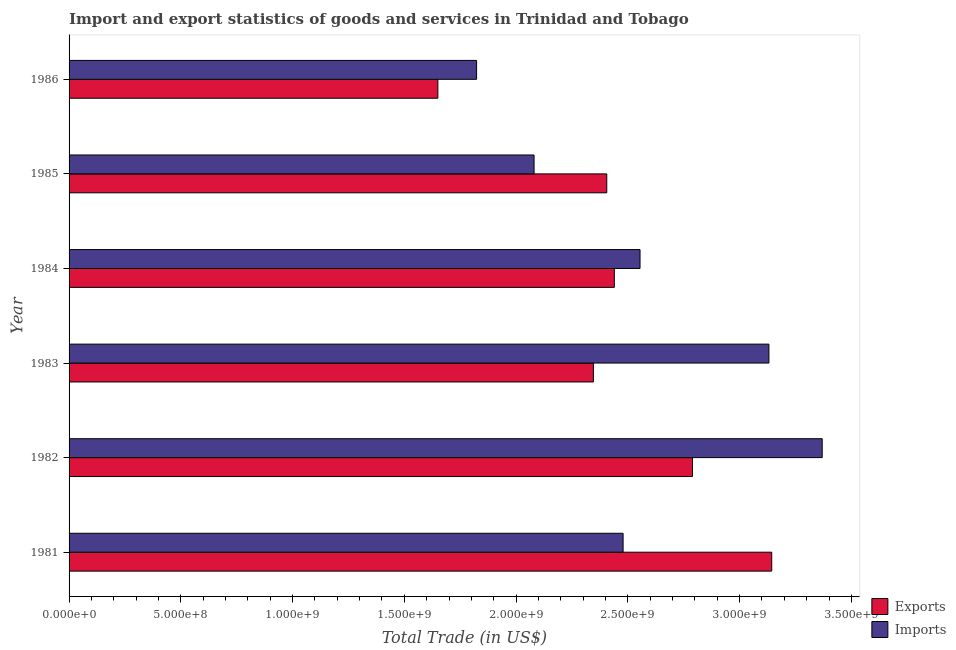How many different coloured bars are there?
Offer a very short reply. 2. How many groups of bars are there?
Offer a terse response. 6. Are the number of bars per tick equal to the number of legend labels?
Provide a succinct answer. Yes. How many bars are there on the 2nd tick from the top?
Give a very brief answer. 2. What is the label of the 4th group of bars from the top?
Keep it short and to the point. 1983. In how many cases, is the number of bars for a given year not equal to the number of legend labels?
Offer a terse response. 0. What is the imports of goods and services in 1983?
Your answer should be very brief. 3.13e+09. Across all years, what is the maximum export of goods and services?
Ensure brevity in your answer.  3.14e+09. Across all years, what is the minimum export of goods and services?
Ensure brevity in your answer.  1.65e+09. In which year was the imports of goods and services minimum?
Offer a terse response. 1986. What is the total export of goods and services in the graph?
Keep it short and to the point. 1.48e+1. What is the difference between the export of goods and services in 1981 and that in 1986?
Keep it short and to the point. 1.49e+09. What is the difference between the imports of goods and services in 1985 and the export of goods and services in 1982?
Your response must be concise. -7.09e+08. What is the average imports of goods and services per year?
Offer a terse response. 2.57e+09. In the year 1986, what is the difference between the imports of goods and services and export of goods and services?
Keep it short and to the point. 1.73e+08. What is the ratio of the imports of goods and services in 1982 to that in 1983?
Keep it short and to the point. 1.08. Is the imports of goods and services in 1983 less than that in 1986?
Offer a terse response. No. Is the difference between the export of goods and services in 1985 and 1986 greater than the difference between the imports of goods and services in 1985 and 1986?
Ensure brevity in your answer.  Yes. What is the difference between the highest and the second highest imports of goods and services?
Ensure brevity in your answer.  2.38e+08. What is the difference between the highest and the lowest imports of goods and services?
Keep it short and to the point. 1.55e+09. In how many years, is the imports of goods and services greater than the average imports of goods and services taken over all years?
Make the answer very short. 2. Is the sum of the imports of goods and services in 1981 and 1983 greater than the maximum export of goods and services across all years?
Offer a very short reply. Yes. What does the 1st bar from the top in 1985 represents?
Provide a short and direct response. Imports. What does the 1st bar from the bottom in 1986 represents?
Offer a very short reply. Exports. Are all the bars in the graph horizontal?
Your response must be concise. Yes. What is the difference between two consecutive major ticks on the X-axis?
Your response must be concise. 5.00e+08. Does the graph contain grids?
Offer a terse response. No. Where does the legend appear in the graph?
Offer a very short reply. Bottom right. How many legend labels are there?
Provide a succinct answer. 2. What is the title of the graph?
Keep it short and to the point. Import and export statistics of goods and services in Trinidad and Tobago. What is the label or title of the X-axis?
Give a very brief answer. Total Trade (in US$). What is the Total Trade (in US$) in Exports in 1981?
Keep it short and to the point. 3.14e+09. What is the Total Trade (in US$) in Imports in 1981?
Offer a terse response. 2.48e+09. What is the Total Trade (in US$) in Exports in 1982?
Your response must be concise. 2.79e+09. What is the Total Trade (in US$) of Imports in 1982?
Your response must be concise. 3.37e+09. What is the Total Trade (in US$) of Exports in 1983?
Ensure brevity in your answer.  2.35e+09. What is the Total Trade (in US$) of Imports in 1983?
Provide a short and direct response. 3.13e+09. What is the Total Trade (in US$) in Exports in 1984?
Your response must be concise. 2.44e+09. What is the Total Trade (in US$) of Imports in 1984?
Give a very brief answer. 2.55e+09. What is the Total Trade (in US$) of Exports in 1985?
Provide a short and direct response. 2.41e+09. What is the Total Trade (in US$) in Imports in 1985?
Your answer should be compact. 2.08e+09. What is the Total Trade (in US$) of Exports in 1986?
Offer a very short reply. 1.65e+09. What is the Total Trade (in US$) of Imports in 1986?
Provide a succinct answer. 1.82e+09. Across all years, what is the maximum Total Trade (in US$) in Exports?
Make the answer very short. 3.14e+09. Across all years, what is the maximum Total Trade (in US$) in Imports?
Ensure brevity in your answer.  3.37e+09. Across all years, what is the minimum Total Trade (in US$) of Exports?
Offer a very short reply. 1.65e+09. Across all years, what is the minimum Total Trade (in US$) in Imports?
Offer a very short reply. 1.82e+09. What is the total Total Trade (in US$) of Exports in the graph?
Give a very brief answer. 1.48e+1. What is the total Total Trade (in US$) of Imports in the graph?
Your response must be concise. 1.54e+1. What is the difference between the Total Trade (in US$) of Exports in 1981 and that in 1982?
Keep it short and to the point. 3.55e+08. What is the difference between the Total Trade (in US$) in Imports in 1981 and that in 1982?
Your response must be concise. -8.91e+08. What is the difference between the Total Trade (in US$) of Exports in 1981 and that in 1983?
Your answer should be very brief. 7.98e+08. What is the difference between the Total Trade (in US$) in Imports in 1981 and that in 1983?
Your answer should be compact. -6.52e+08. What is the difference between the Total Trade (in US$) of Exports in 1981 and that in 1984?
Give a very brief answer. 7.04e+08. What is the difference between the Total Trade (in US$) in Imports in 1981 and that in 1984?
Your response must be concise. -7.58e+07. What is the difference between the Total Trade (in US$) in Exports in 1981 and that in 1985?
Make the answer very short. 7.38e+08. What is the difference between the Total Trade (in US$) in Imports in 1981 and that in 1985?
Your response must be concise. 3.98e+08. What is the difference between the Total Trade (in US$) in Exports in 1981 and that in 1986?
Your answer should be compact. 1.49e+09. What is the difference between the Total Trade (in US$) in Imports in 1981 and that in 1986?
Your answer should be very brief. 6.55e+08. What is the difference between the Total Trade (in US$) in Exports in 1982 and that in 1983?
Your response must be concise. 4.43e+08. What is the difference between the Total Trade (in US$) of Imports in 1982 and that in 1983?
Your answer should be compact. 2.38e+08. What is the difference between the Total Trade (in US$) in Exports in 1982 and that in 1984?
Your answer should be very brief. 3.50e+08. What is the difference between the Total Trade (in US$) in Imports in 1982 and that in 1984?
Provide a short and direct response. 8.15e+08. What is the difference between the Total Trade (in US$) of Exports in 1982 and that in 1985?
Ensure brevity in your answer.  3.83e+08. What is the difference between the Total Trade (in US$) in Imports in 1982 and that in 1985?
Keep it short and to the point. 1.29e+09. What is the difference between the Total Trade (in US$) in Exports in 1982 and that in 1986?
Ensure brevity in your answer.  1.14e+09. What is the difference between the Total Trade (in US$) in Imports in 1982 and that in 1986?
Offer a terse response. 1.55e+09. What is the difference between the Total Trade (in US$) of Exports in 1983 and that in 1984?
Provide a short and direct response. -9.37e+07. What is the difference between the Total Trade (in US$) in Imports in 1983 and that in 1984?
Your answer should be compact. 5.77e+08. What is the difference between the Total Trade (in US$) in Exports in 1983 and that in 1985?
Provide a succinct answer. -5.99e+07. What is the difference between the Total Trade (in US$) in Imports in 1983 and that in 1985?
Your answer should be very brief. 1.05e+09. What is the difference between the Total Trade (in US$) of Exports in 1983 and that in 1986?
Provide a succinct answer. 6.96e+08. What is the difference between the Total Trade (in US$) of Imports in 1983 and that in 1986?
Your answer should be very brief. 1.31e+09. What is the difference between the Total Trade (in US$) of Exports in 1984 and that in 1985?
Your response must be concise. 3.39e+07. What is the difference between the Total Trade (in US$) of Imports in 1984 and that in 1985?
Your answer should be very brief. 4.74e+08. What is the difference between the Total Trade (in US$) in Exports in 1984 and that in 1986?
Offer a very short reply. 7.90e+08. What is the difference between the Total Trade (in US$) in Imports in 1984 and that in 1986?
Provide a short and direct response. 7.31e+08. What is the difference between the Total Trade (in US$) in Exports in 1985 and that in 1986?
Provide a succinct answer. 7.56e+08. What is the difference between the Total Trade (in US$) in Imports in 1985 and that in 1986?
Your answer should be compact. 2.57e+08. What is the difference between the Total Trade (in US$) of Exports in 1981 and the Total Trade (in US$) of Imports in 1982?
Offer a terse response. -2.26e+08. What is the difference between the Total Trade (in US$) in Exports in 1981 and the Total Trade (in US$) in Imports in 1983?
Offer a very short reply. 1.25e+07. What is the difference between the Total Trade (in US$) in Exports in 1981 and the Total Trade (in US$) in Imports in 1984?
Keep it short and to the point. 5.89e+08. What is the difference between the Total Trade (in US$) in Exports in 1981 and the Total Trade (in US$) in Imports in 1985?
Offer a very short reply. 1.06e+09. What is the difference between the Total Trade (in US$) of Exports in 1981 and the Total Trade (in US$) of Imports in 1986?
Your answer should be compact. 1.32e+09. What is the difference between the Total Trade (in US$) of Exports in 1982 and the Total Trade (in US$) of Imports in 1983?
Provide a short and direct response. -3.42e+08. What is the difference between the Total Trade (in US$) of Exports in 1982 and the Total Trade (in US$) of Imports in 1984?
Your answer should be very brief. 2.35e+08. What is the difference between the Total Trade (in US$) in Exports in 1982 and the Total Trade (in US$) in Imports in 1985?
Ensure brevity in your answer.  7.09e+08. What is the difference between the Total Trade (in US$) in Exports in 1982 and the Total Trade (in US$) in Imports in 1986?
Your answer should be compact. 9.66e+08. What is the difference between the Total Trade (in US$) of Exports in 1983 and the Total Trade (in US$) of Imports in 1984?
Give a very brief answer. -2.09e+08. What is the difference between the Total Trade (in US$) of Exports in 1983 and the Total Trade (in US$) of Imports in 1985?
Make the answer very short. 2.65e+08. What is the difference between the Total Trade (in US$) of Exports in 1983 and the Total Trade (in US$) of Imports in 1986?
Give a very brief answer. 5.22e+08. What is the difference between the Total Trade (in US$) in Exports in 1984 and the Total Trade (in US$) in Imports in 1985?
Ensure brevity in your answer.  3.59e+08. What is the difference between the Total Trade (in US$) of Exports in 1984 and the Total Trade (in US$) of Imports in 1986?
Provide a short and direct response. 6.16e+08. What is the difference between the Total Trade (in US$) of Exports in 1985 and the Total Trade (in US$) of Imports in 1986?
Your response must be concise. 5.82e+08. What is the average Total Trade (in US$) of Exports per year?
Ensure brevity in your answer.  2.46e+09. What is the average Total Trade (in US$) in Imports per year?
Offer a very short reply. 2.57e+09. In the year 1981, what is the difference between the Total Trade (in US$) in Exports and Total Trade (in US$) in Imports?
Your answer should be compact. 6.65e+08. In the year 1982, what is the difference between the Total Trade (in US$) in Exports and Total Trade (in US$) in Imports?
Keep it short and to the point. -5.80e+08. In the year 1983, what is the difference between the Total Trade (in US$) in Exports and Total Trade (in US$) in Imports?
Provide a short and direct response. -7.85e+08. In the year 1984, what is the difference between the Total Trade (in US$) in Exports and Total Trade (in US$) in Imports?
Your answer should be compact. -1.15e+08. In the year 1985, what is the difference between the Total Trade (in US$) of Exports and Total Trade (in US$) of Imports?
Ensure brevity in your answer.  3.25e+08. In the year 1986, what is the difference between the Total Trade (in US$) of Exports and Total Trade (in US$) of Imports?
Your answer should be very brief. -1.73e+08. What is the ratio of the Total Trade (in US$) in Exports in 1981 to that in 1982?
Keep it short and to the point. 1.13. What is the ratio of the Total Trade (in US$) of Imports in 1981 to that in 1982?
Give a very brief answer. 0.74. What is the ratio of the Total Trade (in US$) in Exports in 1981 to that in 1983?
Offer a very short reply. 1.34. What is the ratio of the Total Trade (in US$) in Imports in 1981 to that in 1983?
Your answer should be very brief. 0.79. What is the ratio of the Total Trade (in US$) in Exports in 1981 to that in 1984?
Your answer should be compact. 1.29. What is the ratio of the Total Trade (in US$) of Imports in 1981 to that in 1984?
Offer a terse response. 0.97. What is the ratio of the Total Trade (in US$) in Exports in 1981 to that in 1985?
Provide a short and direct response. 1.31. What is the ratio of the Total Trade (in US$) of Imports in 1981 to that in 1985?
Give a very brief answer. 1.19. What is the ratio of the Total Trade (in US$) in Exports in 1981 to that in 1986?
Keep it short and to the point. 1.91. What is the ratio of the Total Trade (in US$) in Imports in 1981 to that in 1986?
Offer a very short reply. 1.36. What is the ratio of the Total Trade (in US$) of Exports in 1982 to that in 1983?
Keep it short and to the point. 1.19. What is the ratio of the Total Trade (in US$) in Imports in 1982 to that in 1983?
Offer a very short reply. 1.08. What is the ratio of the Total Trade (in US$) in Exports in 1982 to that in 1984?
Keep it short and to the point. 1.14. What is the ratio of the Total Trade (in US$) in Imports in 1982 to that in 1984?
Offer a terse response. 1.32. What is the ratio of the Total Trade (in US$) in Exports in 1982 to that in 1985?
Keep it short and to the point. 1.16. What is the ratio of the Total Trade (in US$) of Imports in 1982 to that in 1985?
Your answer should be compact. 1.62. What is the ratio of the Total Trade (in US$) in Exports in 1982 to that in 1986?
Your answer should be compact. 1.69. What is the ratio of the Total Trade (in US$) of Imports in 1982 to that in 1986?
Your answer should be compact. 1.85. What is the ratio of the Total Trade (in US$) of Exports in 1983 to that in 1984?
Give a very brief answer. 0.96. What is the ratio of the Total Trade (in US$) of Imports in 1983 to that in 1984?
Keep it short and to the point. 1.23. What is the ratio of the Total Trade (in US$) of Exports in 1983 to that in 1985?
Make the answer very short. 0.98. What is the ratio of the Total Trade (in US$) of Imports in 1983 to that in 1985?
Your response must be concise. 1.51. What is the ratio of the Total Trade (in US$) in Exports in 1983 to that in 1986?
Your response must be concise. 1.42. What is the ratio of the Total Trade (in US$) in Imports in 1983 to that in 1986?
Offer a terse response. 1.72. What is the ratio of the Total Trade (in US$) in Exports in 1984 to that in 1985?
Provide a succinct answer. 1.01. What is the ratio of the Total Trade (in US$) in Imports in 1984 to that in 1985?
Your answer should be very brief. 1.23. What is the ratio of the Total Trade (in US$) of Exports in 1984 to that in 1986?
Keep it short and to the point. 1.48. What is the ratio of the Total Trade (in US$) in Imports in 1984 to that in 1986?
Make the answer very short. 1.4. What is the ratio of the Total Trade (in US$) in Exports in 1985 to that in 1986?
Provide a short and direct response. 1.46. What is the ratio of the Total Trade (in US$) of Imports in 1985 to that in 1986?
Give a very brief answer. 1.14. What is the difference between the highest and the second highest Total Trade (in US$) of Exports?
Provide a succinct answer. 3.55e+08. What is the difference between the highest and the second highest Total Trade (in US$) of Imports?
Your answer should be very brief. 2.38e+08. What is the difference between the highest and the lowest Total Trade (in US$) in Exports?
Make the answer very short. 1.49e+09. What is the difference between the highest and the lowest Total Trade (in US$) of Imports?
Your response must be concise. 1.55e+09. 